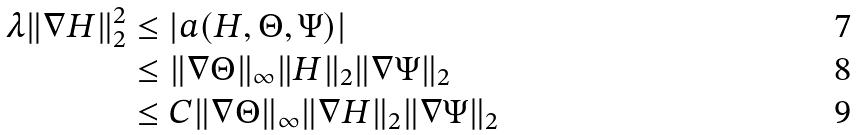<formula> <loc_0><loc_0><loc_500><loc_500>\lambda \| \nabla H \| _ { 2 } ^ { 2 } & \leq | a ( H , \Theta , \Psi ) | \\ & \leq \| \nabla \Theta \| _ { \infty } \| H \| _ { 2 } \| \nabla \Psi \| _ { 2 } \\ & \leq C \| \nabla \Theta \| _ { \infty } \| \nabla H \| _ { 2 } \| \nabla \Psi \| _ { 2 }</formula> 